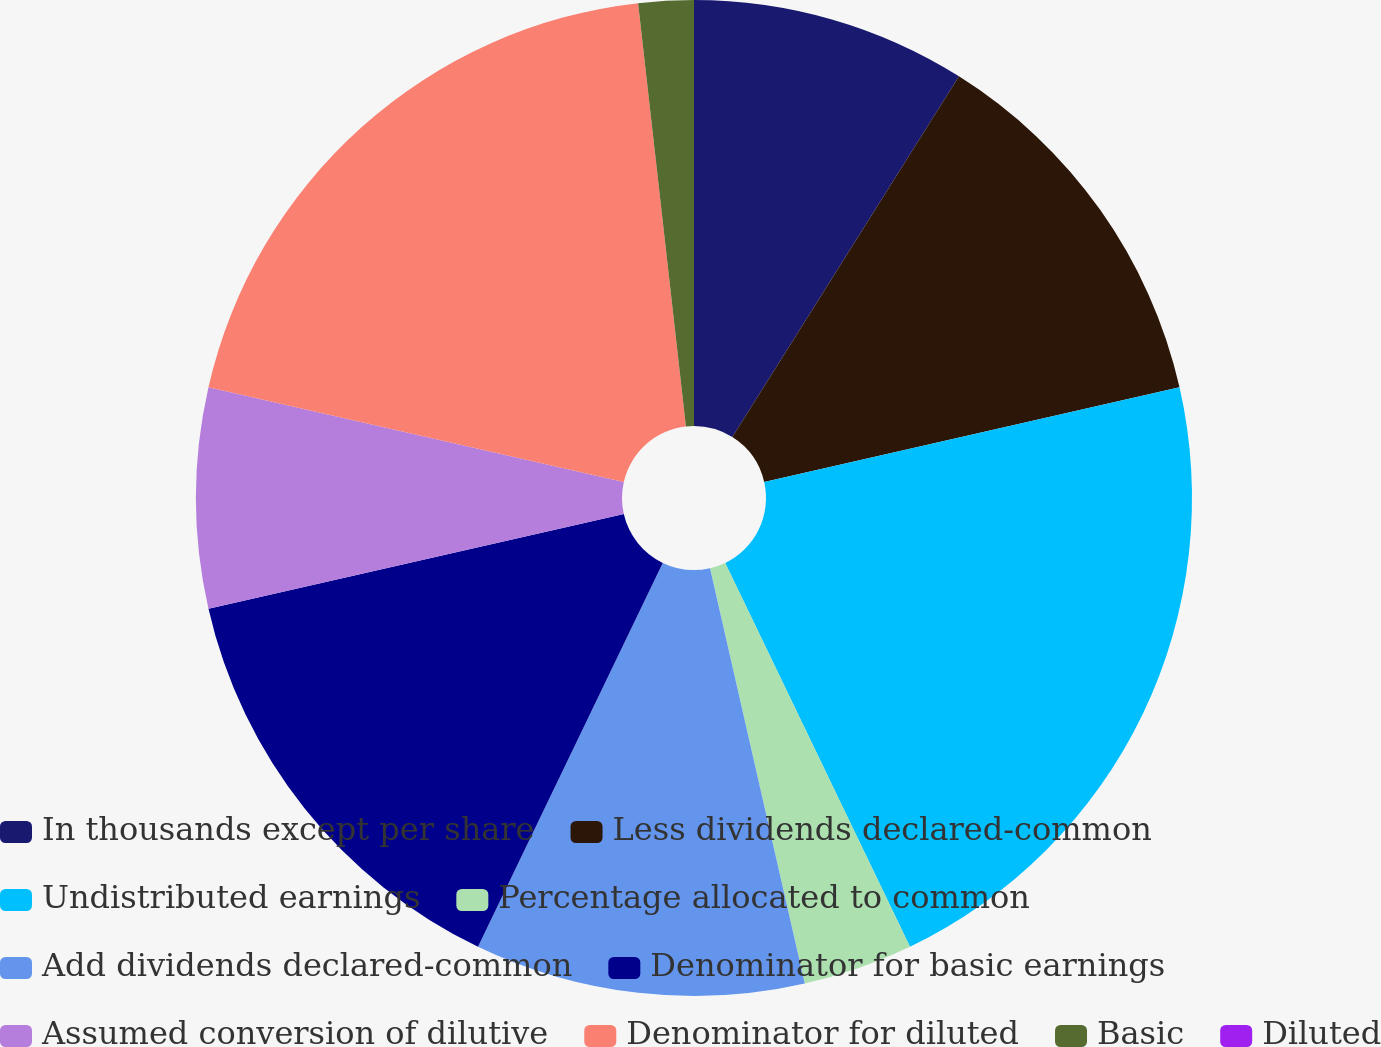Convert chart to OTSL. <chart><loc_0><loc_0><loc_500><loc_500><pie_chart><fcel>In thousands except per share<fcel>Less dividends declared-common<fcel>Undistributed earnings<fcel>Percentage allocated to common<fcel>Add dividends declared-common<fcel>Denominator for basic earnings<fcel>Assumed conversion of dilutive<fcel>Denominator for diluted<fcel>Basic<fcel>Diluted<nl><fcel>8.93%<fcel>12.5%<fcel>21.43%<fcel>3.57%<fcel>10.71%<fcel>14.29%<fcel>7.14%<fcel>19.64%<fcel>1.79%<fcel>0.0%<nl></chart> 